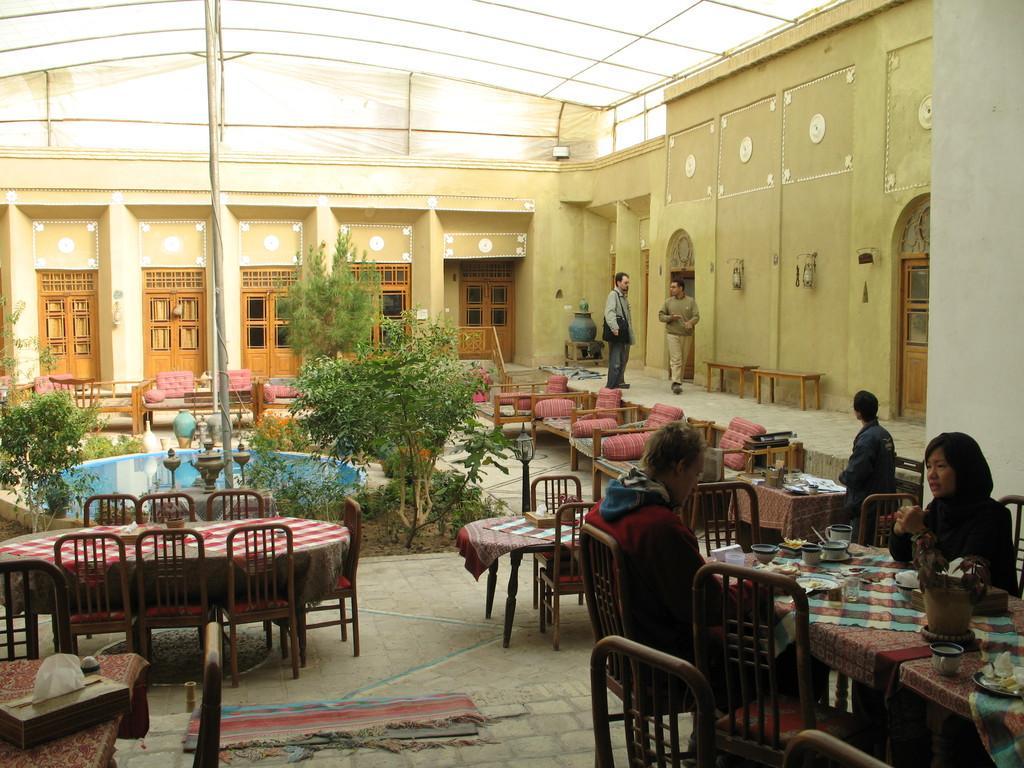Can you describe this image briefly? In this image I can see few people were two of them are sitting on chairs and rest all are standing. I can also see number of chairs and tables. In the background I can see few trees. 